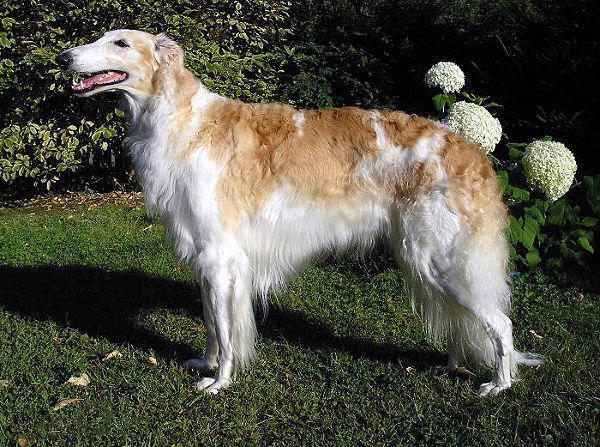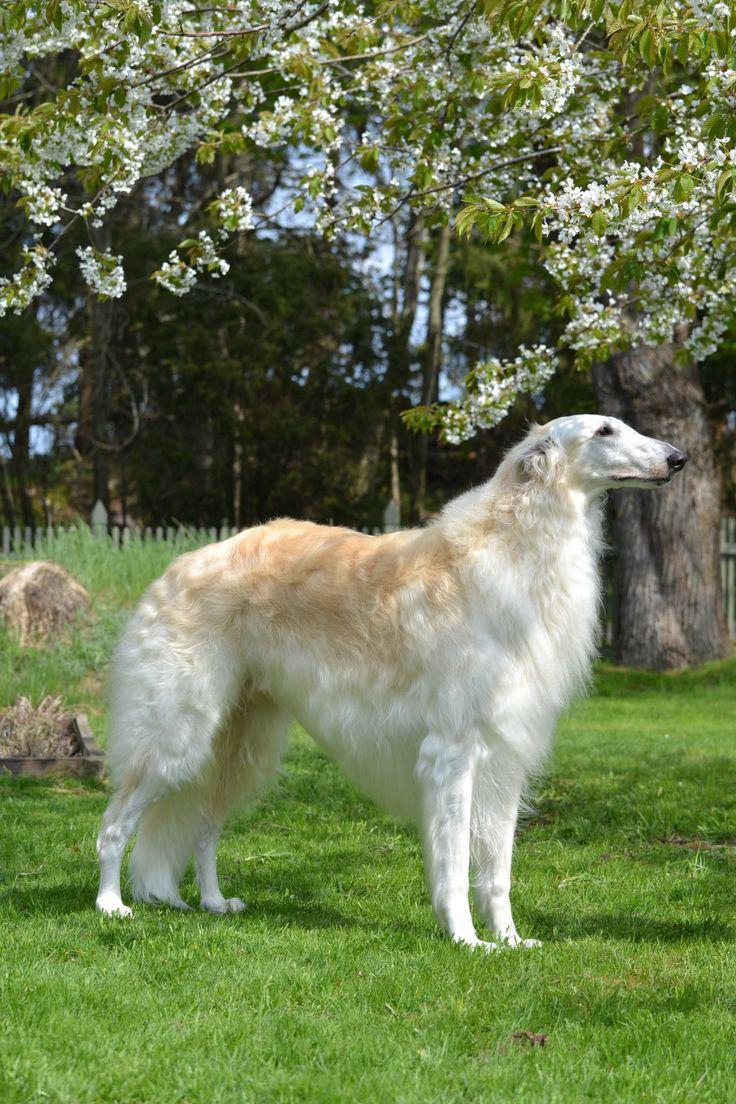The first image is the image on the left, the second image is the image on the right. Assess this claim about the two images: "there is only one human on the image.". Correct or not? Answer yes or no. No. The first image is the image on the left, the second image is the image on the right. Assess this claim about the two images: "Each image features one dog, and the dogs are facing opposite directions.". Correct or not? Answer yes or no. Yes. 